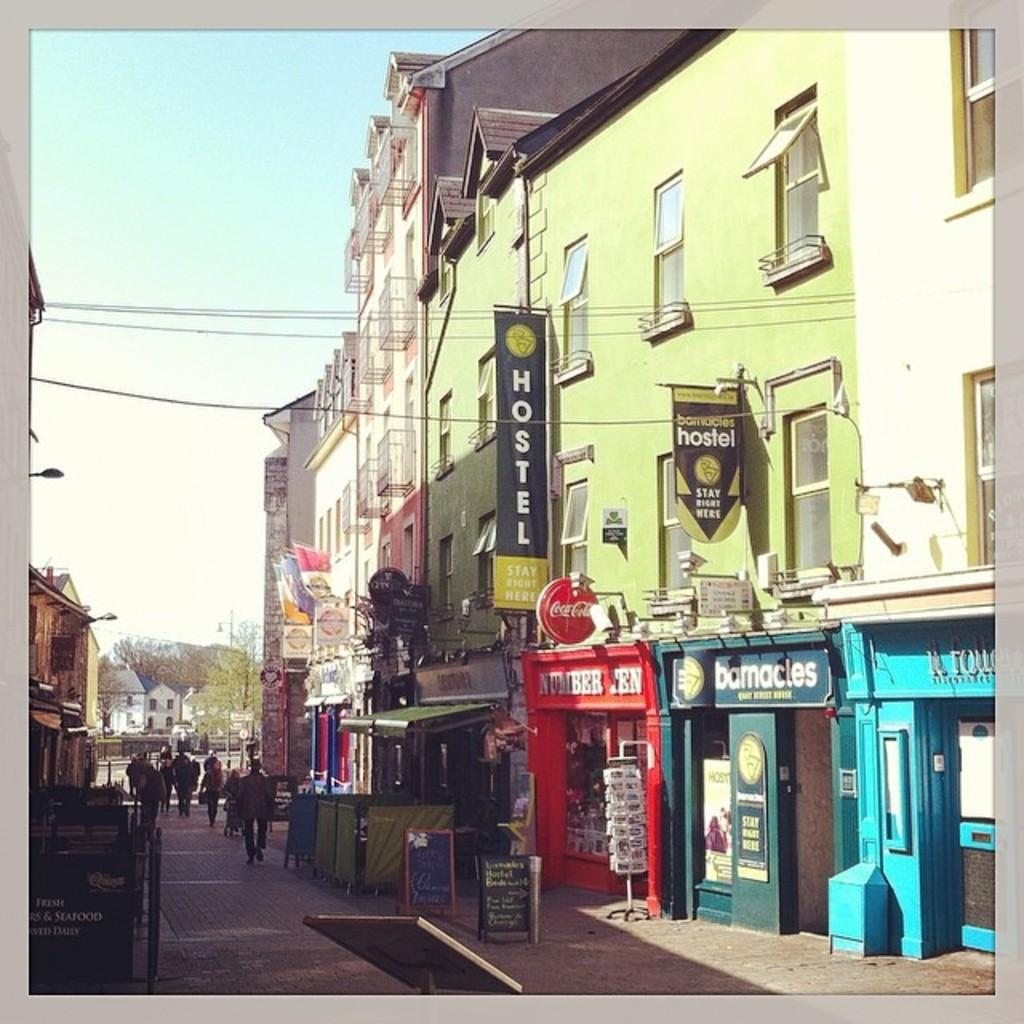What can be seen in the sky in the image? The sky is visible in the image. What type of structures are present in the image? There are buildings in the image. What other natural elements can be seen in the image? Trees are present in the image. What additional items are hanging in the image? Banners are in the image. What architectural features can be observed on the buildings? Windows are visible in the image. Are there any signs or notices in the image? Boards with text are in the image. What type of utility infrastructure is present in the image? Wires are present in the image. What is the activity of the people in the image? People are walking in the image. Can you describe any other unspecified objects in the image? There are other unspecified objects in the image. What type of milk is being served in the image? There is no milk present in the image. 